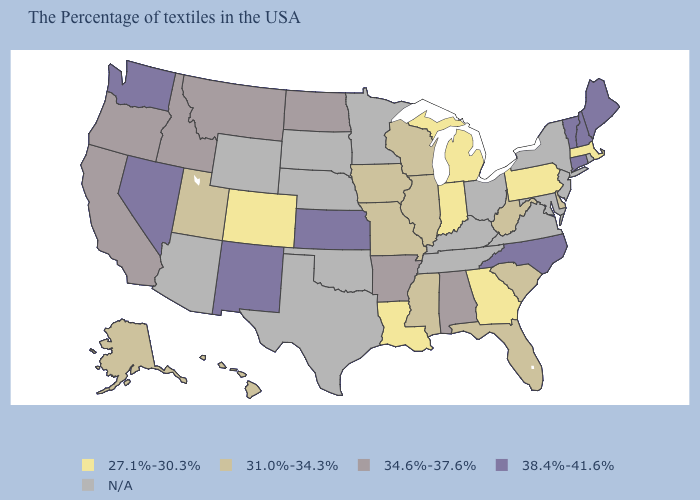What is the lowest value in the West?
Be succinct. 27.1%-30.3%. What is the lowest value in the West?
Keep it brief. 27.1%-30.3%. How many symbols are there in the legend?
Be succinct. 5. Name the states that have a value in the range N/A?
Be succinct. Rhode Island, New York, New Jersey, Maryland, Virginia, Ohio, Kentucky, Tennessee, Minnesota, Nebraska, Oklahoma, Texas, South Dakota, Wyoming, Arizona. How many symbols are there in the legend?
Give a very brief answer. 5. Does the map have missing data?
Answer briefly. Yes. Which states have the lowest value in the USA?
Write a very short answer. Massachusetts, Pennsylvania, Georgia, Michigan, Indiana, Louisiana, Colorado. Name the states that have a value in the range N/A?
Concise answer only. Rhode Island, New York, New Jersey, Maryland, Virginia, Ohio, Kentucky, Tennessee, Minnesota, Nebraska, Oklahoma, Texas, South Dakota, Wyoming, Arizona. What is the value of Oklahoma?
Write a very short answer. N/A. What is the value of Montana?
Answer briefly. 34.6%-37.6%. What is the value of Connecticut?
Answer briefly. 38.4%-41.6%. What is the value of Tennessee?
Write a very short answer. N/A. Name the states that have a value in the range N/A?
Keep it brief. Rhode Island, New York, New Jersey, Maryland, Virginia, Ohio, Kentucky, Tennessee, Minnesota, Nebraska, Oklahoma, Texas, South Dakota, Wyoming, Arizona. Does the map have missing data?
Answer briefly. Yes. Name the states that have a value in the range 34.6%-37.6%?
Answer briefly. Alabama, Arkansas, North Dakota, Montana, Idaho, California, Oregon. 